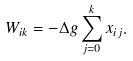<formula> <loc_0><loc_0><loc_500><loc_500>W _ { i k } = - \Delta g \sum _ { j = 0 } ^ { k } x _ { i j } .</formula> 